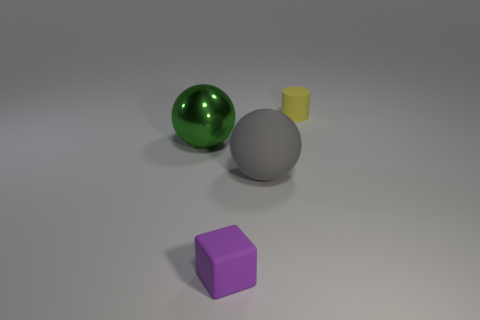How many large balls have the same color as the cube?
Make the answer very short. 0. How big is the sphere right of the sphere to the left of the rubber sphere?
Your answer should be compact. Large. Are there any cubes made of the same material as the gray sphere?
Provide a succinct answer. Yes. What is the material of the gray ball that is the same size as the green object?
Keep it short and to the point. Rubber. Is the color of the big thing that is on the right side of the big green metal object the same as the tiny object that is left of the yellow object?
Your answer should be very brief. No. There is a thing to the left of the small purple thing; are there any big green balls that are in front of it?
Provide a succinct answer. No. There is a small thing in front of the shiny object; does it have the same shape as the big object that is right of the small matte cube?
Provide a short and direct response. No. Is the material of the big ball left of the small purple block the same as the large sphere that is on the right side of the block?
Keep it short and to the point. No. There is a large thing that is on the right side of the small matte thing in front of the big green shiny sphere; what is it made of?
Offer a terse response. Rubber. What shape is the yellow object that is behind the large sphere that is right of the large ball to the left of the purple block?
Keep it short and to the point. Cylinder. 